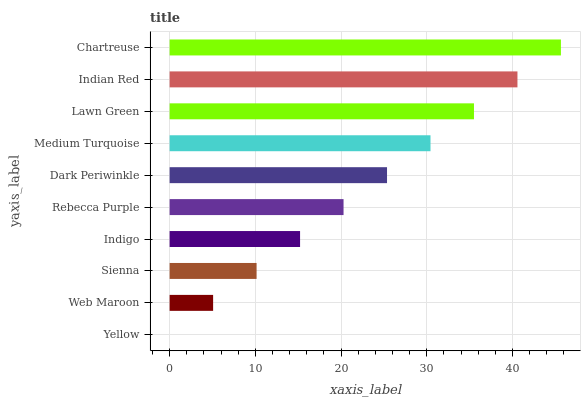Is Yellow the minimum?
Answer yes or no. Yes. Is Chartreuse the maximum?
Answer yes or no. Yes. Is Web Maroon the minimum?
Answer yes or no. No. Is Web Maroon the maximum?
Answer yes or no. No. Is Web Maroon greater than Yellow?
Answer yes or no. Yes. Is Yellow less than Web Maroon?
Answer yes or no. Yes. Is Yellow greater than Web Maroon?
Answer yes or no. No. Is Web Maroon less than Yellow?
Answer yes or no. No. Is Dark Periwinkle the high median?
Answer yes or no. Yes. Is Rebecca Purple the low median?
Answer yes or no. Yes. Is Medium Turquoise the high median?
Answer yes or no. No. Is Medium Turquoise the low median?
Answer yes or no. No. 